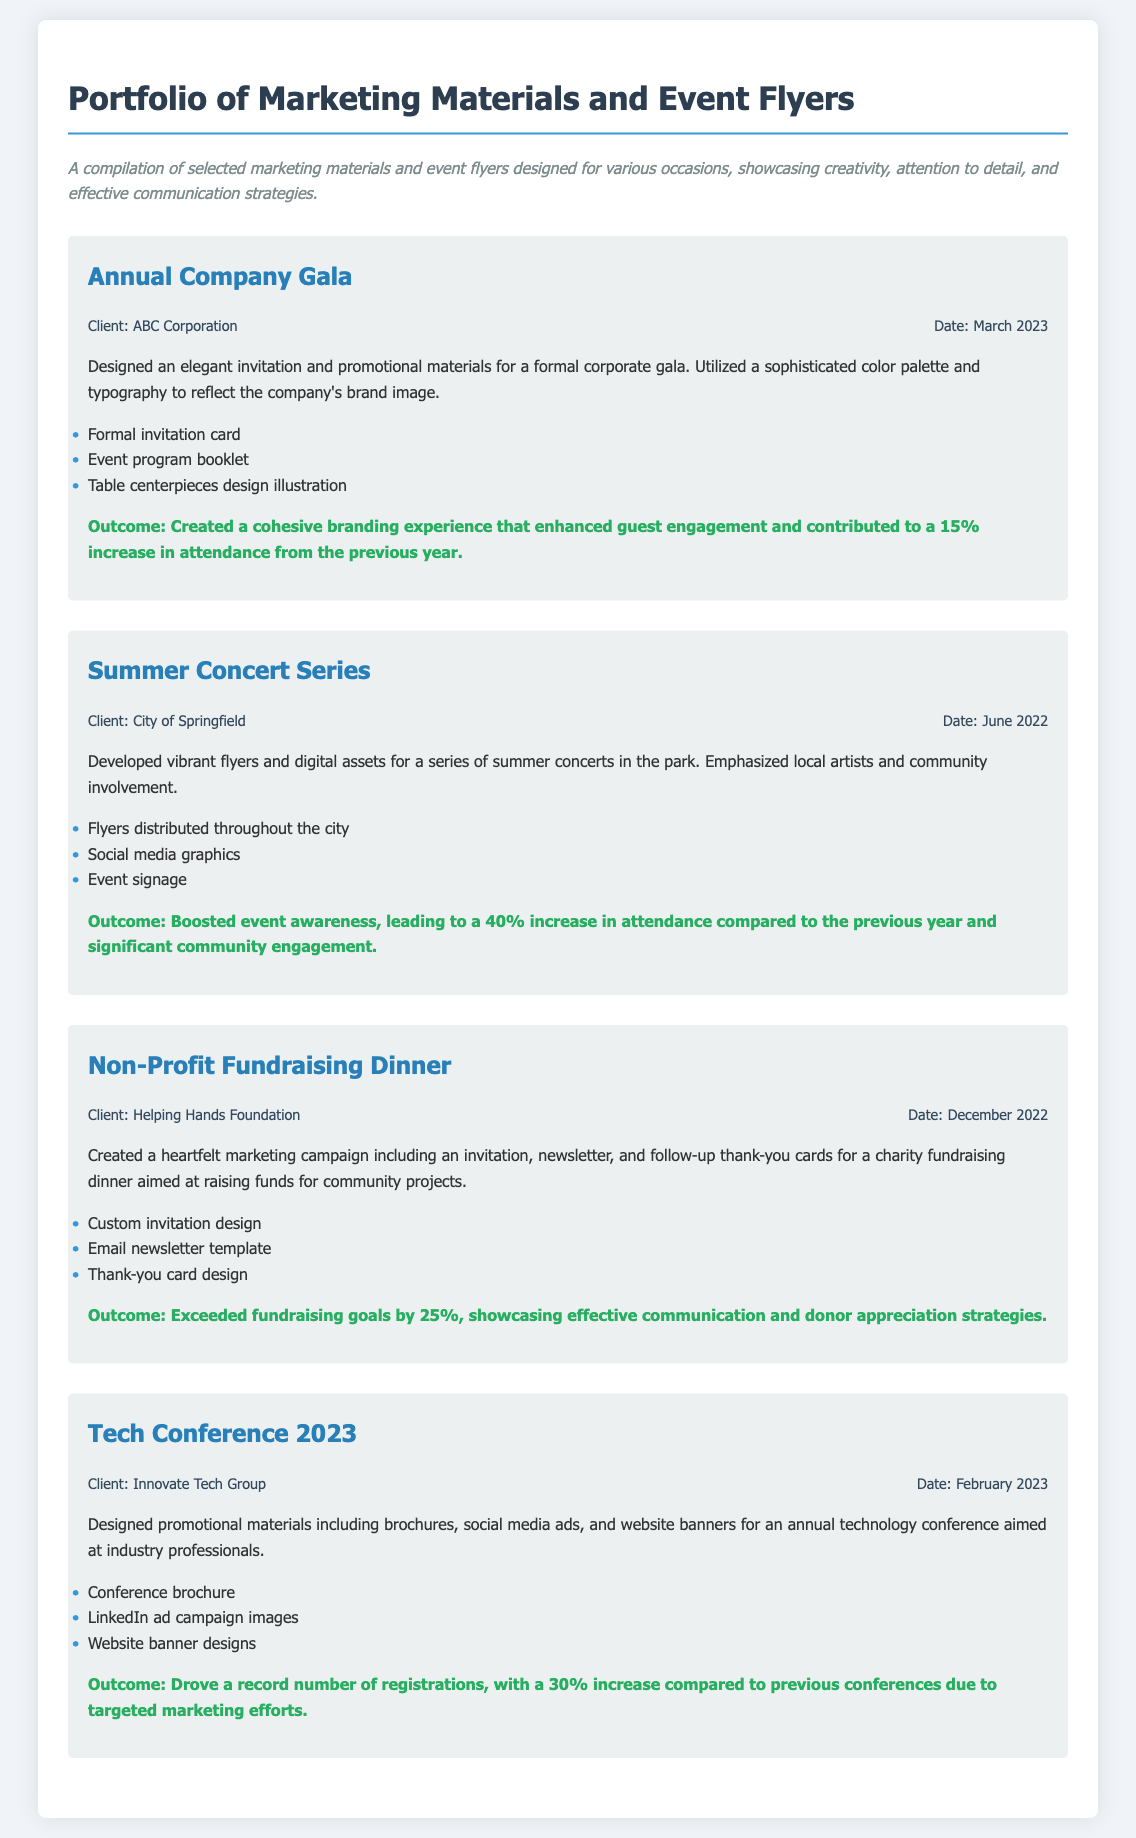what is the title of the portfolio? The title of the portfolio is explicitly stated in the document's heading.
Answer: Portfolio of Marketing Materials and Event Flyers which company hosted the Annual Company Gala? The document explicitly states the client associated with this project.
Answer: ABC Corporation what was the increase in attendance for the Summer Concert Series? The outcome for this project mentions a specific percentage increase in attendance.
Answer: 40% how many components are listed for the Non-Profit Fundraising Dinner project? The number of key components is indicated in the bullets in the project description.
Answer: 3 which month was the Tech Conference 2023 held? The document provides the month of the event in the project details.
Answer: February who was the client for the Summer Concert Series? The document identifies the client for this specific marketing project.
Answer: City of Springfield what type of materials were designed for the Non-Profit Fundraising Dinner? The project description lists specific marketing materials created.
Answer: Invitation, newsletter, thank-you cards what was the outcome of the Annual Company Gala? The outcome section specifies the impact of the project on guest engagement and attendance.
Answer: 15% increase in attendance from the previous year 